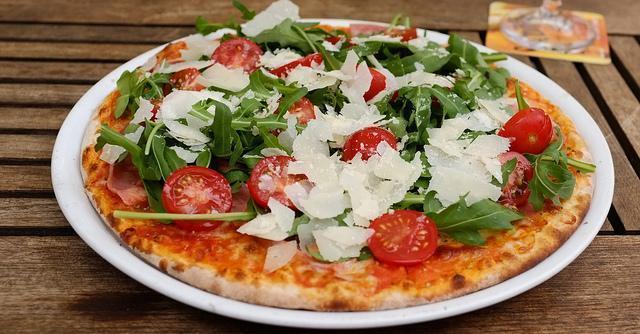Why would someone sit at this table?
Answer the question by selecting the correct answer among the 4 following choices.
Options: To work, to eat, to paint, to sew. To eat. 